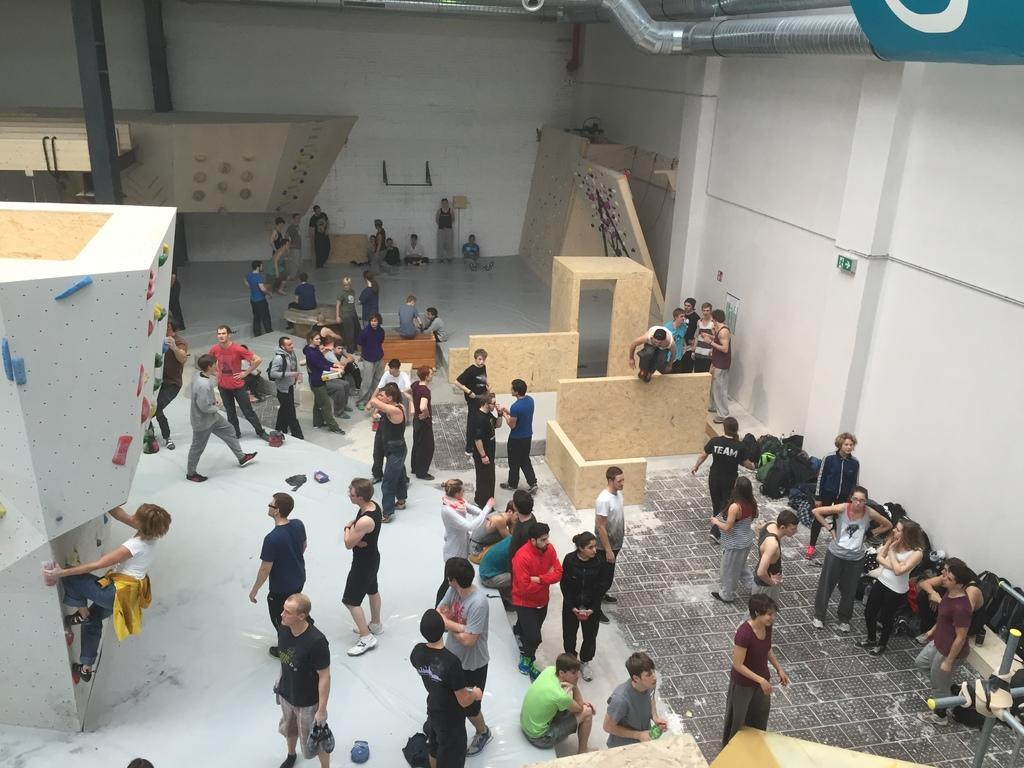What type of location is depicted in the image? The image shows an inner view of a building. What are the people in the image doing? There are people standing and sitting in the image. Can you describe a specific activity being performed by someone in the image? A woman is climbing a wall, which appears to be bouldering. What channel is the advertisement playing on in the image? There is no television or advertisement present in the image. 